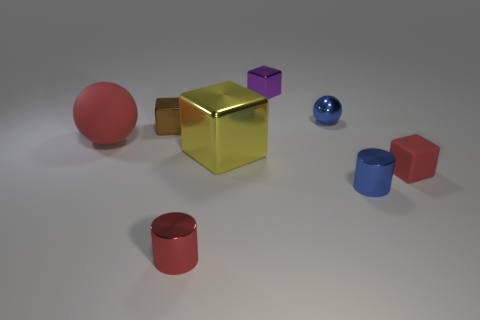The shiny cylinder that is the same color as the small rubber object is what size?
Provide a succinct answer. Small. Are the tiny red object on the left side of the blue sphere and the red ball made of the same material?
Keep it short and to the point. No. Is the number of blocks that are on the left side of the brown metallic thing less than the number of cylinders?
Your answer should be very brief. Yes. There is a matte sphere that is the same size as the yellow object; what is its color?
Your response must be concise. Red. How many red matte things are the same shape as the tiny purple metal object?
Ensure brevity in your answer.  1. There is a rubber thing that is right of the large matte ball; what is its color?
Give a very brief answer. Red. How many matte objects are purple cubes or brown spheres?
Your response must be concise. 0. There is a metallic object that is the same color as the small metal sphere; what is its shape?
Offer a very short reply. Cylinder. What number of cubes have the same size as the red metal thing?
Ensure brevity in your answer.  3. What is the color of the shiny thing that is both left of the yellow cube and behind the small matte cube?
Your answer should be very brief. Brown. 